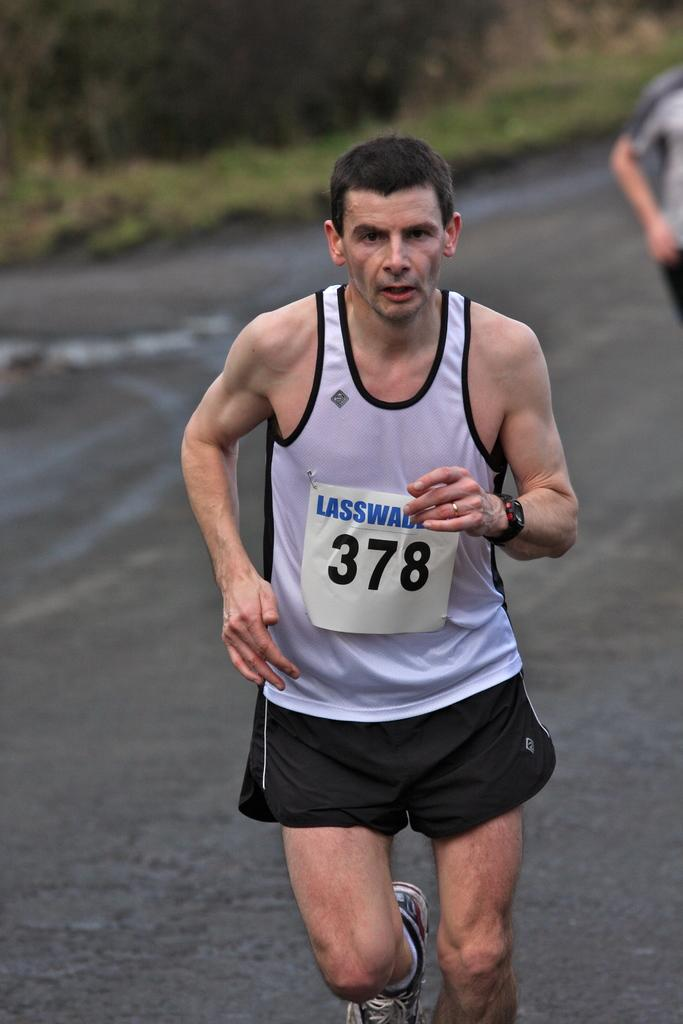Provide a one-sentence caption for the provided image. A runner with the number 378 continues on in the race. 